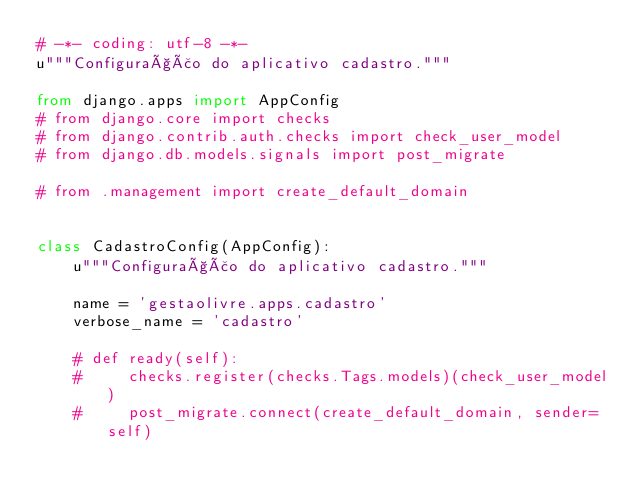<code> <loc_0><loc_0><loc_500><loc_500><_Python_># -*- coding: utf-8 -*-
u"""Configuração do aplicativo cadastro."""

from django.apps import AppConfig
# from django.core import checks
# from django.contrib.auth.checks import check_user_model
# from django.db.models.signals import post_migrate

# from .management import create_default_domain


class CadastroConfig(AppConfig):
    u"""Configuração do aplicativo cadastro."""

    name = 'gestaolivre.apps.cadastro'
    verbose_name = 'cadastro'

    # def ready(self):
    #     checks.register(checks.Tags.models)(check_user_model)
    #     post_migrate.connect(create_default_domain, sender=self)
</code> 